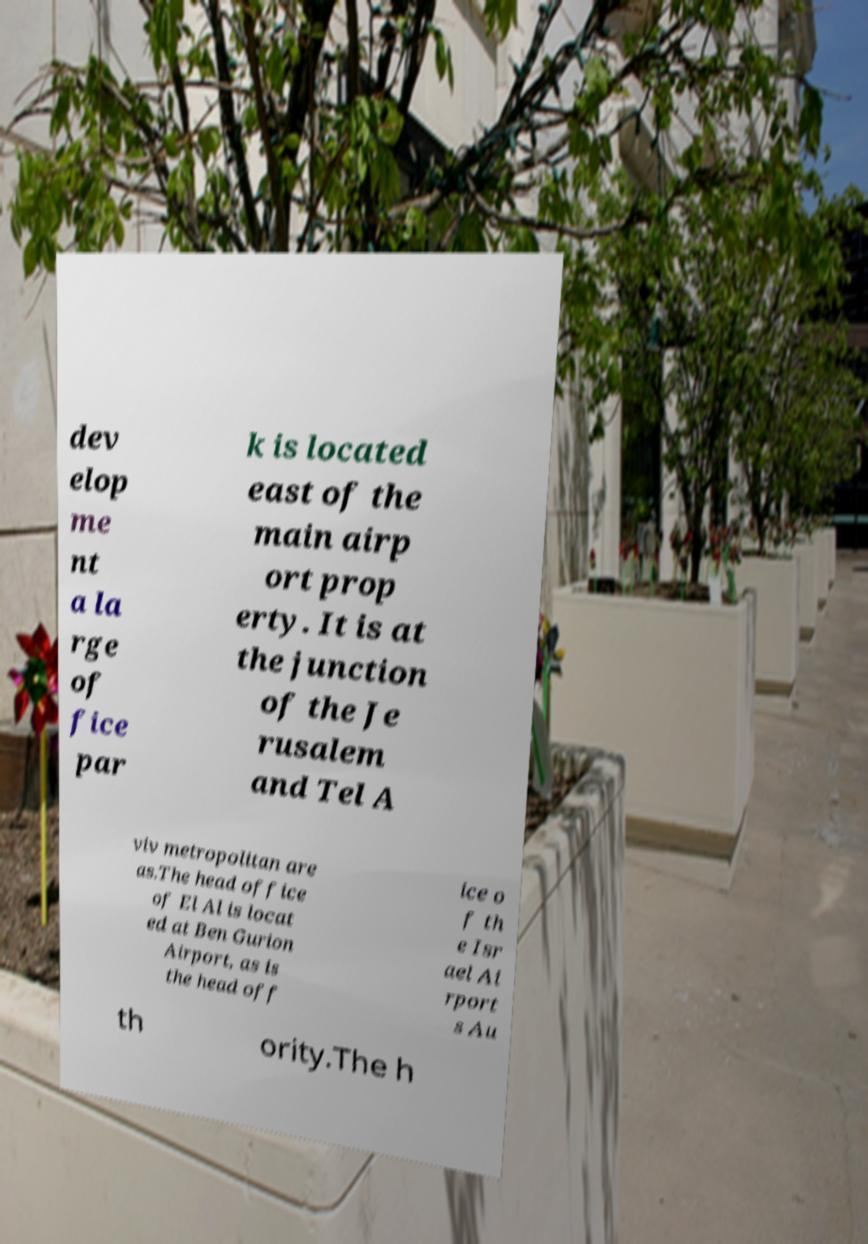Please identify and transcribe the text found in this image. dev elop me nt a la rge of fice par k is located east of the main airp ort prop erty. It is at the junction of the Je rusalem and Tel A viv metropolitan are as.The head office of El Al is locat ed at Ben Gurion Airport, as is the head off ice o f th e Isr ael Ai rport s Au th ority.The h 